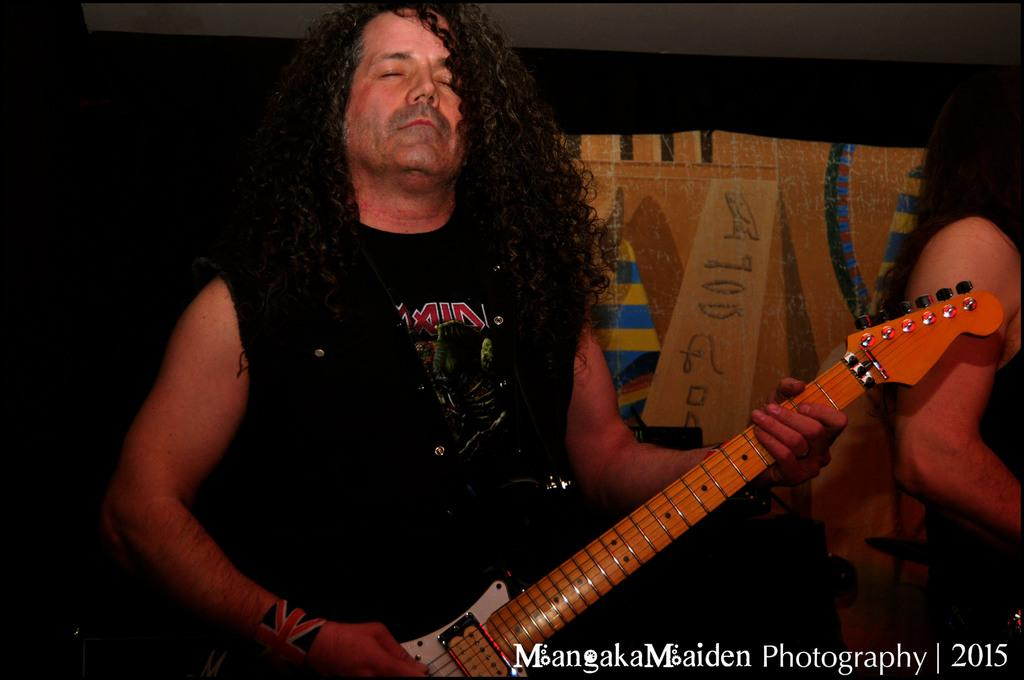What is the main subject of the image? There is a man in the image. What is the man wearing? The man is wearing a black shirt. Can you describe the man's hair? The man has long hair. What is the man holding in the image? The man is holding a guitar. What color is the guitar? The guitar is orange in color. What type of cracker is being distributed by the man in the image? There is no cracker present in the image, nor is there any indication of distribution. 